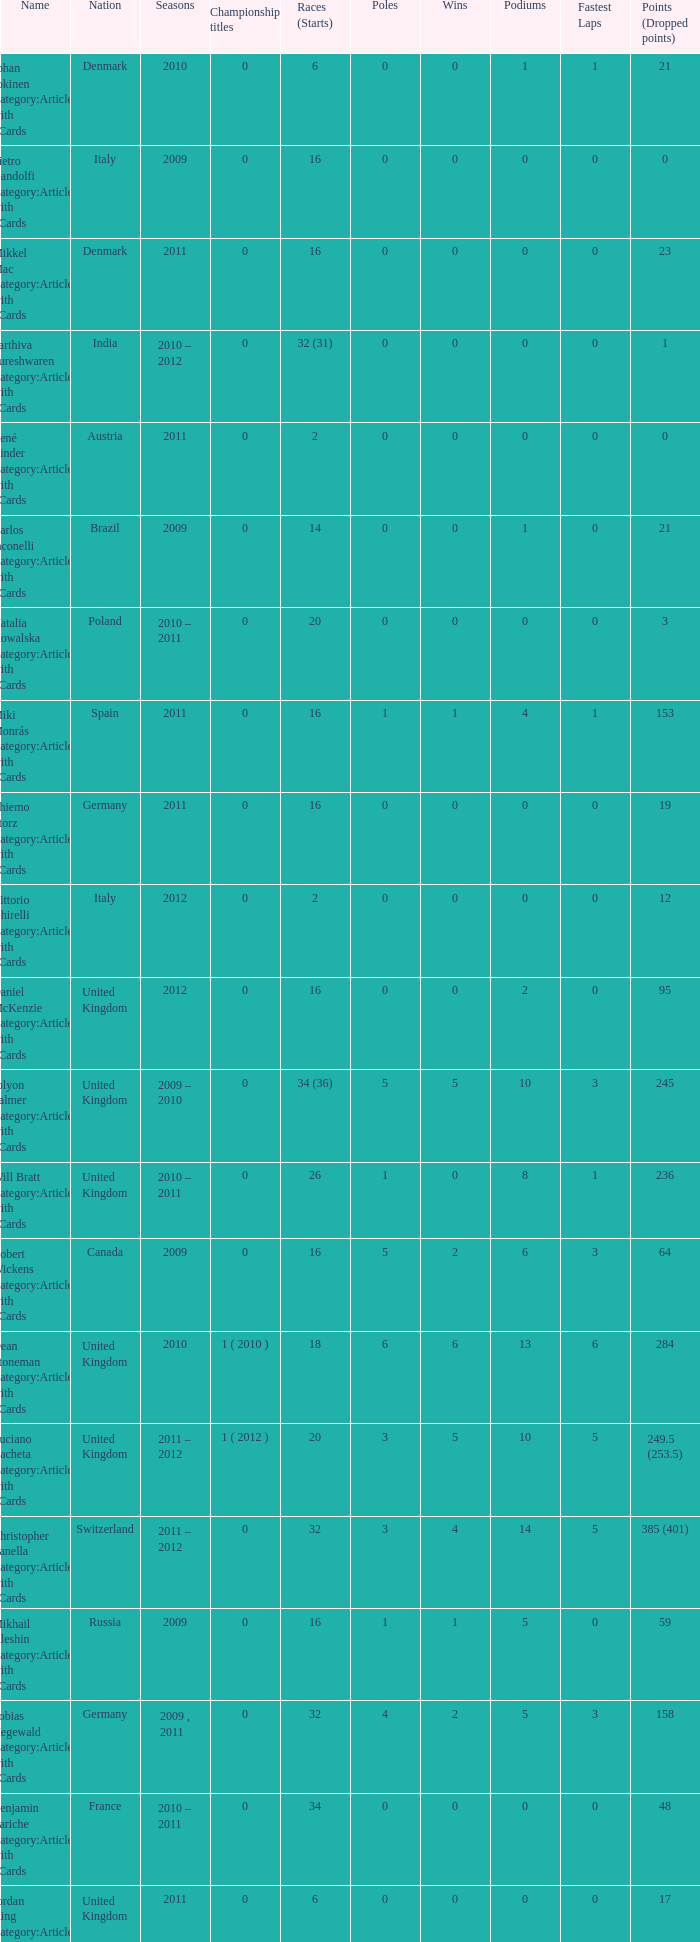What is the minimum amount of poles? 0.0. 